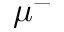Convert formula to latex. <formula><loc_0><loc_0><loc_500><loc_500>\mu ^ { - }</formula> 